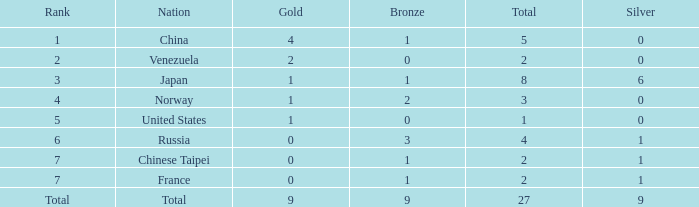What is the average Bronze for rank 3 and total is more than 8? None. 